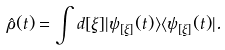Convert formula to latex. <formula><loc_0><loc_0><loc_500><loc_500>\hat { \rho } ( t ) = \int d [ \xi ] | \psi _ { [ \xi ] } ( t ) \rangle \langle \psi _ { [ \xi ] } ( t ) | .</formula> 